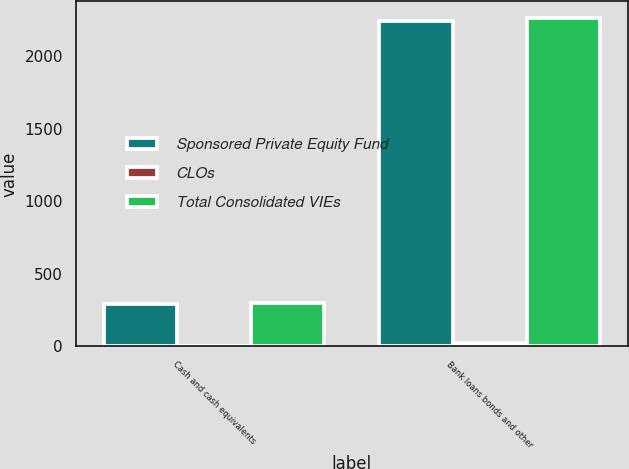<chart> <loc_0><loc_0><loc_500><loc_500><stacked_bar_chart><ecel><fcel>Cash and cash equivalents<fcel>Bank loans bonds and other<nl><fcel>Sponsored Private Equity Fund<fcel>294<fcel>2240<nl><fcel>CLOs<fcel>3<fcel>24<nl><fcel>Total Consolidated VIEs<fcel>297<fcel>2264<nl></chart> 